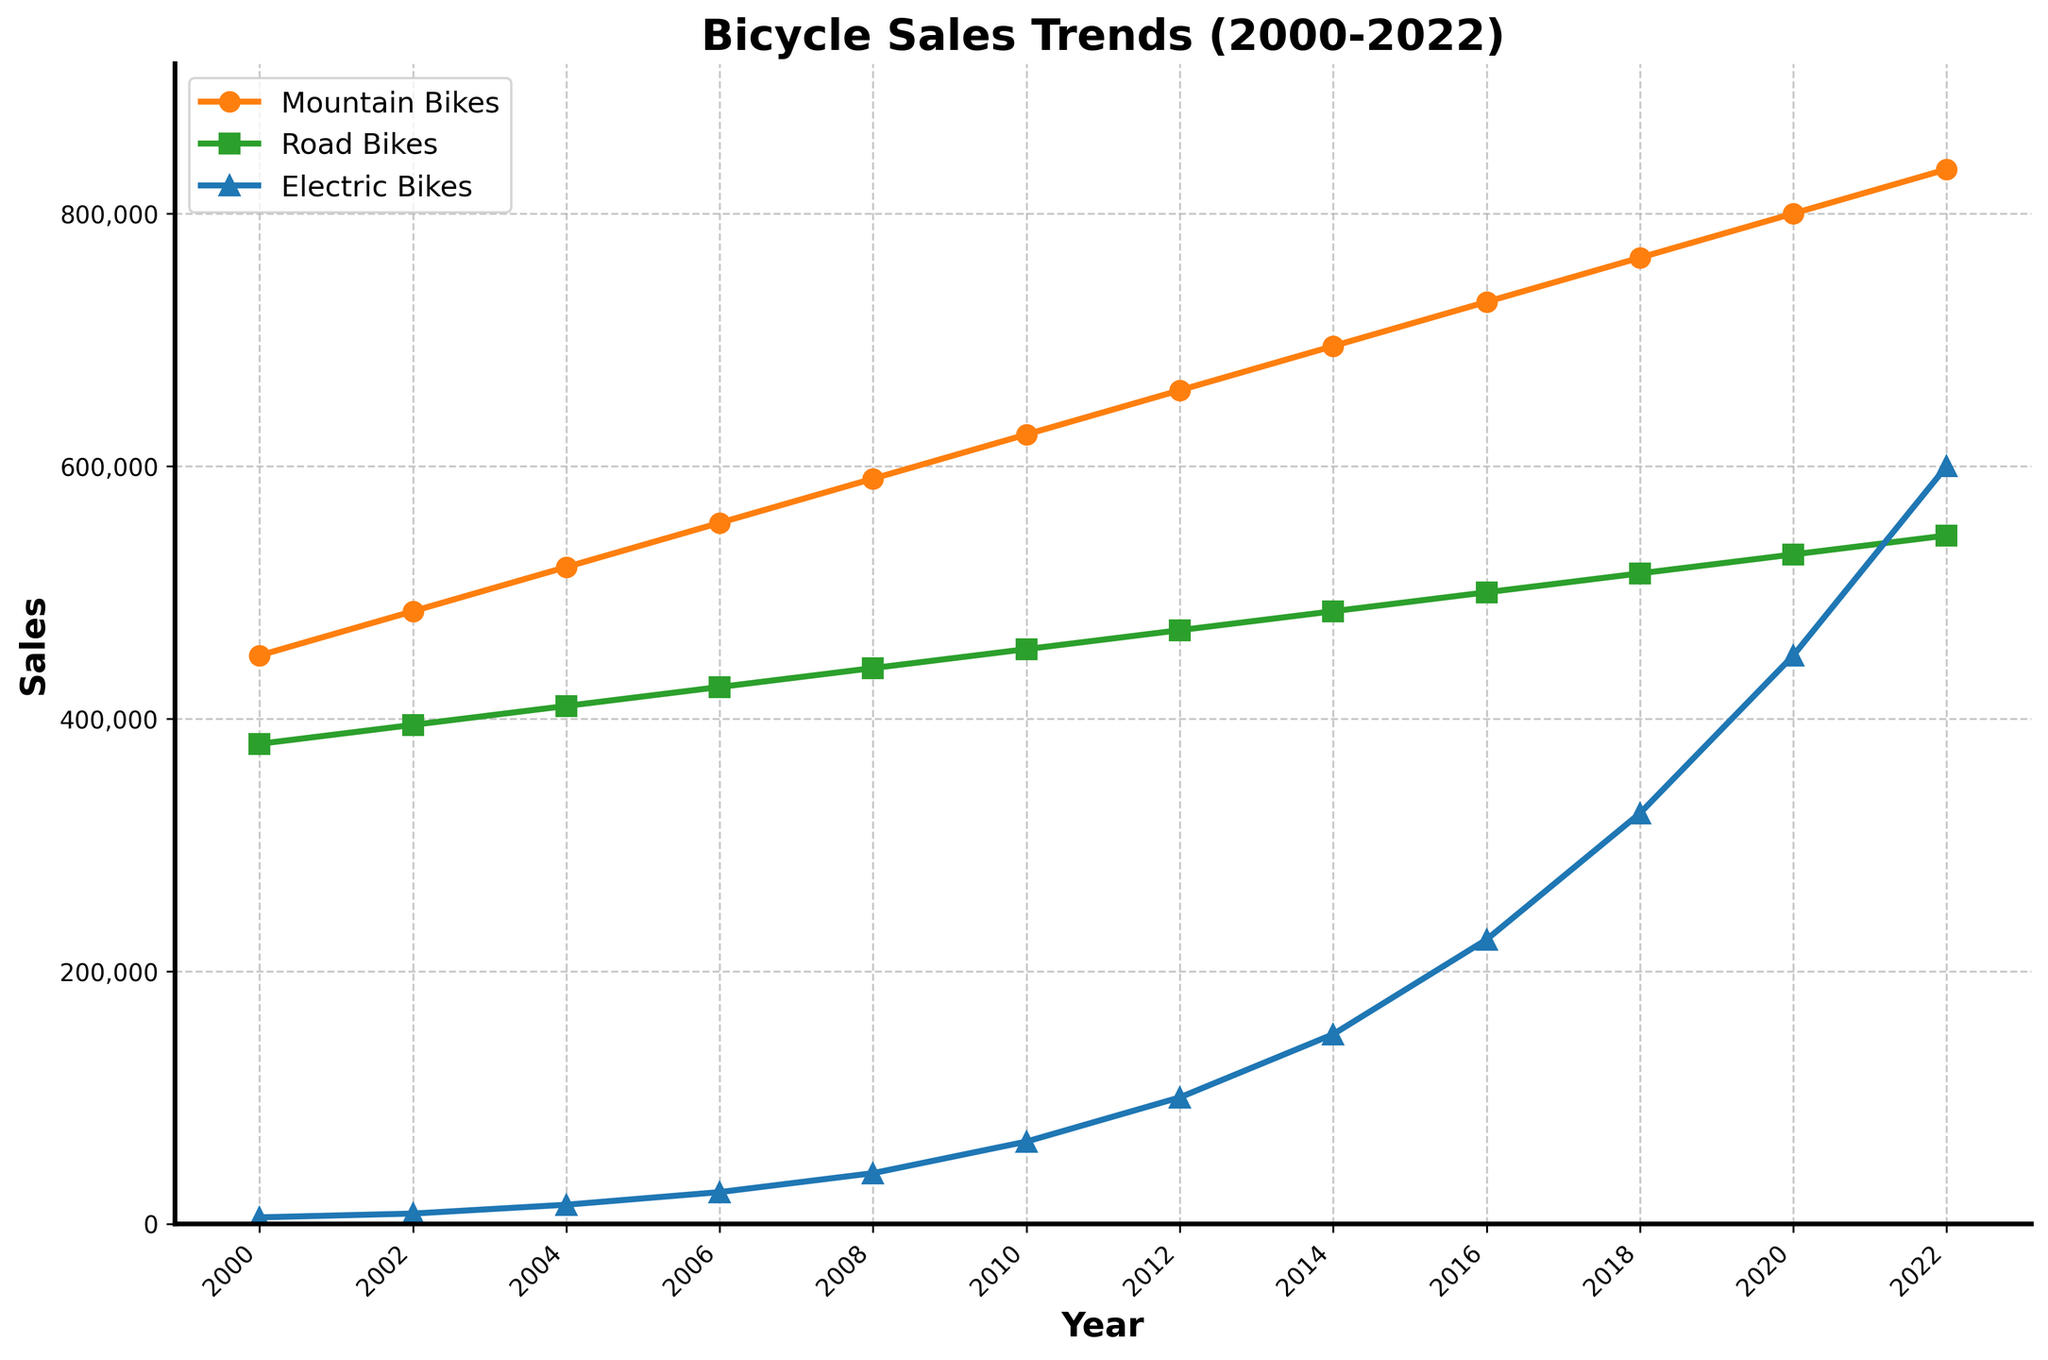What general trend do you notice for Mountain Bikes sales from 2000 to 2022? Sales of Mountain Bikes show a consistent upward trend from 2000 to 2022, increasing steadily each year.
Answer: Increasing trend Which type of bicycle had the highest sales in 2022? To determine this, look at the end of each line in the year 2022. The line for Electric Bikes is the highest, indicating it had the highest sales.
Answer: Electric Bikes In which year did Electric Bikes sales surpass Road Bikes sales? Trace the Electric Bikes and Road Bikes lines to see where Electric Bikes cross above Road Bikes. This occurs between 2016 and 2018.
Answer: 2018 What is the total sales of Road Bikes from 2010 to 2020? Sum the sales of Road Bikes for the years 2010, 2012, 2014, 2016, 2018, and 2020: 455,000 + 470,000 + 485,000 + 500,000 + 515,000 + 530,000 = 2,955,000.
Answer: 2,955,000 Which bicycle type experienced the steepest growth rate? By comparing the slopes of the lines, Electric Bikes show the steepest increase, as the line for Electric Bikes ascends more sharply than the others.
Answer: Electric Bikes How much did Mountain Bikes sales increase from 2000 to 2022? Subtract the sales in 2000 from the sales in 2022: 835,000 - 450,000 = 385,000.
Answer: 385,000 In what year did Mountain Bikes sales reach 600,000? Trace the Mountain Bikes line to find when it intersects the 600,000 sales mark, which happens around 2010.
Answer: 2010 Compare the sales of Road Bikes in 2012 to Mountain Bikes in 2004. Which is higher and by how much? Road Bikes in 2012 had sales of 470,000, while Mountain Bikes in 2004 had sales of 520,000. The difference is 520,000 - 470,000. Therefore, Mountain Bikes in 2004 had higher sales by 50,000.
Answer: Mountain Bikes by 50,000 What is the average annual sales increase of Electric Bikes from 2000 to 2022? Calculate the difference in sales from 2000 to 2022, which is 600,000 - 5,000 = 595,000. Then, divide by the number of years (2022 - 2000 = 22): 595,000 / 22 = 27,045 (approximately).
Answer: 27,045 What visual element indicates the data point for Road Bikes in 2008? The data point for Road Bikes in 2008 is marked by a green square.
Answer: Green square 